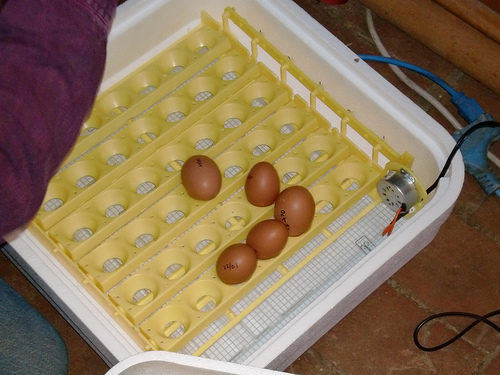<image>
Is there a floor behind the circuit? Yes. From this viewpoint, the floor is positioned behind the circuit, with the circuit partially or fully occluding the floor. 